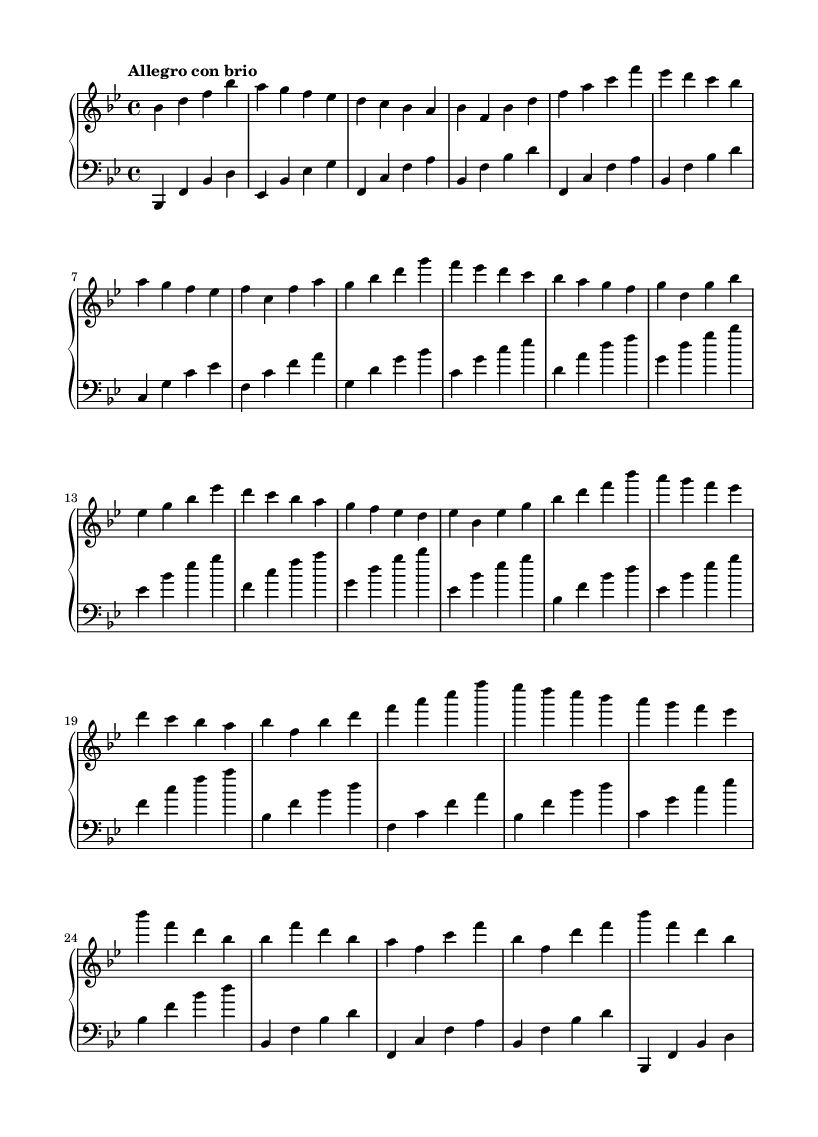What is the key signature of this music? The key signature is indicated at the beginning of the staff and shows two flat symbols, which represent B flat and E flat. This is characteristic of B flat major.
Answer: B flat major What is the time signature of this music? The time signature is located at the beginning of the score, next to the key signature, and is shown as a fraction (4/4), indicating that there are four beats in each measure.
Answer: 4/4 What is the tempo marking for this piece? The tempo marking is found just above the staff and is written as "Allegro con brio," which indicates a fast speed with brilliance.
Answer: Allegro con brio How many measures are in the piece? To determine the number of measures, one can count the vertical lines (bar lines) that separate the measures, which number a total of 16 in this score.
Answer: 16 Which clefs are used in the music? The first staff uses the treble clef as indicated by the symbol at the beginning of the staff, while the second staff uses the bass clef, which is also marked at the beginning.
Answer: Treble and bass clef What is the highest note in the right hand? By analyzing the notes in the right hand, the highest note found is B flat which is the highest pitch in the range of notes played by the right hand in this score.
Answer: B flat Which thematic element is prevalent in the Romantic style exhibited here? The music demonstrates expressive melodies and dynamic contrasts, which are characteristic of Romantic compositions, along with emotional depth highlighted through its harmonic progressions.
Answer: Expressive melodies 